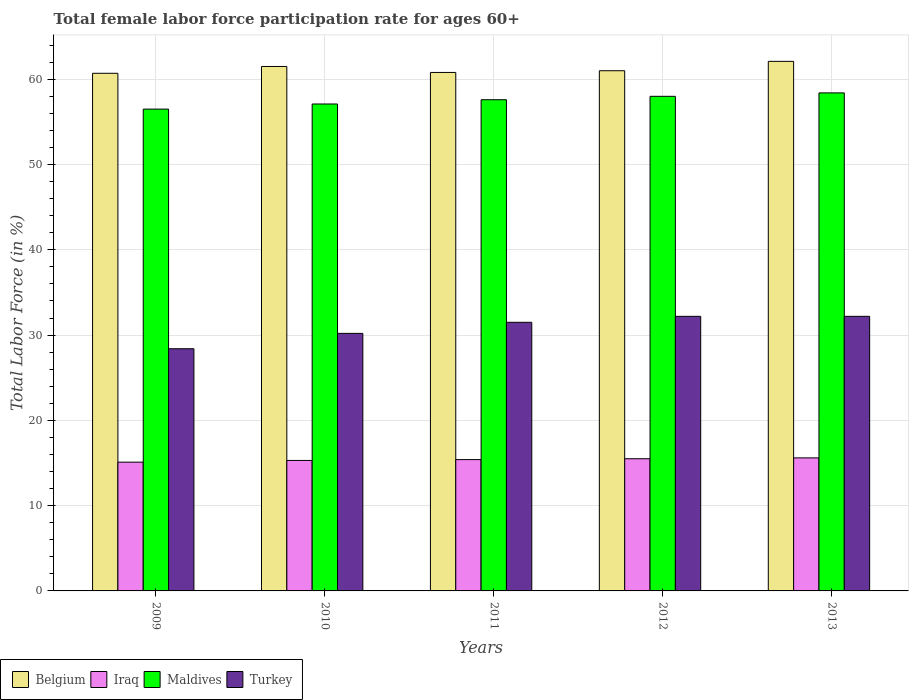How many different coloured bars are there?
Your answer should be compact. 4. How many groups of bars are there?
Your answer should be compact. 5. Are the number of bars per tick equal to the number of legend labels?
Provide a short and direct response. Yes. How many bars are there on the 4th tick from the left?
Your answer should be compact. 4. How many bars are there on the 4th tick from the right?
Offer a very short reply. 4. What is the female labor force participation rate in Iraq in 2012?
Keep it short and to the point. 15.5. Across all years, what is the maximum female labor force participation rate in Belgium?
Keep it short and to the point. 62.1. Across all years, what is the minimum female labor force participation rate in Turkey?
Provide a succinct answer. 28.4. In which year was the female labor force participation rate in Turkey maximum?
Your response must be concise. 2012. In which year was the female labor force participation rate in Maldives minimum?
Your answer should be compact. 2009. What is the total female labor force participation rate in Turkey in the graph?
Offer a terse response. 154.5. What is the difference between the female labor force participation rate in Maldives in 2009 and the female labor force participation rate in Turkey in 2012?
Your response must be concise. 24.3. What is the average female labor force participation rate in Turkey per year?
Ensure brevity in your answer.  30.9. In the year 2011, what is the difference between the female labor force participation rate in Iraq and female labor force participation rate in Maldives?
Offer a terse response. -42.2. In how many years, is the female labor force participation rate in Belgium greater than 40 %?
Offer a terse response. 5. What is the ratio of the female labor force participation rate in Maldives in 2011 to that in 2013?
Keep it short and to the point. 0.99. What is the difference between the highest and the second highest female labor force participation rate in Iraq?
Keep it short and to the point. 0.1. What is the difference between the highest and the lowest female labor force participation rate in Iraq?
Your response must be concise. 0.5. Is the sum of the female labor force participation rate in Iraq in 2010 and 2012 greater than the maximum female labor force participation rate in Maldives across all years?
Give a very brief answer. No. Is it the case that in every year, the sum of the female labor force participation rate in Turkey and female labor force participation rate in Belgium is greater than the sum of female labor force participation rate in Maldives and female labor force participation rate in Iraq?
Offer a very short reply. No. What does the 2nd bar from the right in 2011 represents?
Your response must be concise. Maldives. Are the values on the major ticks of Y-axis written in scientific E-notation?
Provide a short and direct response. No. Does the graph contain any zero values?
Keep it short and to the point. No. Does the graph contain grids?
Give a very brief answer. Yes. How many legend labels are there?
Your answer should be very brief. 4. How are the legend labels stacked?
Your answer should be compact. Horizontal. What is the title of the graph?
Make the answer very short. Total female labor force participation rate for ages 60+. Does "Djibouti" appear as one of the legend labels in the graph?
Offer a terse response. No. What is the Total Labor Force (in %) of Belgium in 2009?
Ensure brevity in your answer.  60.7. What is the Total Labor Force (in %) of Iraq in 2009?
Keep it short and to the point. 15.1. What is the Total Labor Force (in %) of Maldives in 2009?
Give a very brief answer. 56.5. What is the Total Labor Force (in %) in Turkey in 2009?
Your response must be concise. 28.4. What is the Total Labor Force (in %) in Belgium in 2010?
Give a very brief answer. 61.5. What is the Total Labor Force (in %) of Iraq in 2010?
Give a very brief answer. 15.3. What is the Total Labor Force (in %) in Maldives in 2010?
Provide a short and direct response. 57.1. What is the Total Labor Force (in %) of Turkey in 2010?
Your answer should be compact. 30.2. What is the Total Labor Force (in %) of Belgium in 2011?
Offer a terse response. 60.8. What is the Total Labor Force (in %) in Iraq in 2011?
Give a very brief answer. 15.4. What is the Total Labor Force (in %) in Maldives in 2011?
Make the answer very short. 57.6. What is the Total Labor Force (in %) in Turkey in 2011?
Provide a succinct answer. 31.5. What is the Total Labor Force (in %) in Belgium in 2012?
Ensure brevity in your answer.  61. What is the Total Labor Force (in %) in Maldives in 2012?
Keep it short and to the point. 58. What is the Total Labor Force (in %) of Turkey in 2012?
Provide a short and direct response. 32.2. What is the Total Labor Force (in %) of Belgium in 2013?
Provide a short and direct response. 62.1. What is the Total Labor Force (in %) in Iraq in 2013?
Give a very brief answer. 15.6. What is the Total Labor Force (in %) in Maldives in 2013?
Keep it short and to the point. 58.4. What is the Total Labor Force (in %) in Turkey in 2013?
Ensure brevity in your answer.  32.2. Across all years, what is the maximum Total Labor Force (in %) in Belgium?
Your answer should be compact. 62.1. Across all years, what is the maximum Total Labor Force (in %) in Iraq?
Your answer should be very brief. 15.6. Across all years, what is the maximum Total Labor Force (in %) of Maldives?
Provide a short and direct response. 58.4. Across all years, what is the maximum Total Labor Force (in %) in Turkey?
Provide a succinct answer. 32.2. Across all years, what is the minimum Total Labor Force (in %) in Belgium?
Your answer should be very brief. 60.7. Across all years, what is the minimum Total Labor Force (in %) of Iraq?
Make the answer very short. 15.1. Across all years, what is the minimum Total Labor Force (in %) of Maldives?
Offer a very short reply. 56.5. Across all years, what is the minimum Total Labor Force (in %) of Turkey?
Your answer should be very brief. 28.4. What is the total Total Labor Force (in %) of Belgium in the graph?
Ensure brevity in your answer.  306.1. What is the total Total Labor Force (in %) in Iraq in the graph?
Your answer should be compact. 76.9. What is the total Total Labor Force (in %) in Maldives in the graph?
Your answer should be compact. 287.6. What is the total Total Labor Force (in %) in Turkey in the graph?
Keep it short and to the point. 154.5. What is the difference between the Total Labor Force (in %) in Belgium in 2009 and that in 2010?
Your response must be concise. -0.8. What is the difference between the Total Labor Force (in %) of Iraq in 2009 and that in 2010?
Provide a succinct answer. -0.2. What is the difference between the Total Labor Force (in %) of Maldives in 2009 and that in 2010?
Ensure brevity in your answer.  -0.6. What is the difference between the Total Labor Force (in %) of Turkey in 2009 and that in 2010?
Give a very brief answer. -1.8. What is the difference between the Total Labor Force (in %) of Maldives in 2009 and that in 2011?
Your answer should be compact. -1.1. What is the difference between the Total Labor Force (in %) of Turkey in 2009 and that in 2011?
Your response must be concise. -3.1. What is the difference between the Total Labor Force (in %) of Iraq in 2009 and that in 2012?
Your response must be concise. -0.4. What is the difference between the Total Labor Force (in %) of Maldives in 2009 and that in 2012?
Ensure brevity in your answer.  -1.5. What is the difference between the Total Labor Force (in %) of Turkey in 2009 and that in 2012?
Ensure brevity in your answer.  -3.8. What is the difference between the Total Labor Force (in %) in Belgium in 2009 and that in 2013?
Make the answer very short. -1.4. What is the difference between the Total Labor Force (in %) of Belgium in 2010 and that in 2012?
Ensure brevity in your answer.  0.5. What is the difference between the Total Labor Force (in %) of Maldives in 2010 and that in 2012?
Make the answer very short. -0.9. What is the difference between the Total Labor Force (in %) of Belgium in 2010 and that in 2013?
Keep it short and to the point. -0.6. What is the difference between the Total Labor Force (in %) of Maldives in 2010 and that in 2013?
Ensure brevity in your answer.  -1.3. What is the difference between the Total Labor Force (in %) in Belgium in 2011 and that in 2012?
Make the answer very short. -0.2. What is the difference between the Total Labor Force (in %) of Iraq in 2011 and that in 2012?
Provide a short and direct response. -0.1. What is the difference between the Total Labor Force (in %) in Maldives in 2011 and that in 2012?
Your answer should be compact. -0.4. What is the difference between the Total Labor Force (in %) of Belgium in 2011 and that in 2013?
Offer a terse response. -1.3. What is the difference between the Total Labor Force (in %) in Maldives in 2011 and that in 2013?
Your answer should be compact. -0.8. What is the difference between the Total Labor Force (in %) in Belgium in 2012 and that in 2013?
Offer a very short reply. -1.1. What is the difference between the Total Labor Force (in %) of Iraq in 2012 and that in 2013?
Provide a short and direct response. -0.1. What is the difference between the Total Labor Force (in %) of Maldives in 2012 and that in 2013?
Keep it short and to the point. -0.4. What is the difference between the Total Labor Force (in %) of Belgium in 2009 and the Total Labor Force (in %) of Iraq in 2010?
Your response must be concise. 45.4. What is the difference between the Total Labor Force (in %) of Belgium in 2009 and the Total Labor Force (in %) of Maldives in 2010?
Keep it short and to the point. 3.6. What is the difference between the Total Labor Force (in %) of Belgium in 2009 and the Total Labor Force (in %) of Turkey in 2010?
Give a very brief answer. 30.5. What is the difference between the Total Labor Force (in %) in Iraq in 2009 and the Total Labor Force (in %) in Maldives in 2010?
Keep it short and to the point. -42. What is the difference between the Total Labor Force (in %) of Iraq in 2009 and the Total Labor Force (in %) of Turkey in 2010?
Make the answer very short. -15.1. What is the difference between the Total Labor Force (in %) in Maldives in 2009 and the Total Labor Force (in %) in Turkey in 2010?
Provide a short and direct response. 26.3. What is the difference between the Total Labor Force (in %) of Belgium in 2009 and the Total Labor Force (in %) of Iraq in 2011?
Your answer should be very brief. 45.3. What is the difference between the Total Labor Force (in %) in Belgium in 2009 and the Total Labor Force (in %) in Maldives in 2011?
Offer a terse response. 3.1. What is the difference between the Total Labor Force (in %) in Belgium in 2009 and the Total Labor Force (in %) in Turkey in 2011?
Your answer should be compact. 29.2. What is the difference between the Total Labor Force (in %) of Iraq in 2009 and the Total Labor Force (in %) of Maldives in 2011?
Your answer should be very brief. -42.5. What is the difference between the Total Labor Force (in %) in Iraq in 2009 and the Total Labor Force (in %) in Turkey in 2011?
Your answer should be very brief. -16.4. What is the difference between the Total Labor Force (in %) of Belgium in 2009 and the Total Labor Force (in %) of Iraq in 2012?
Make the answer very short. 45.2. What is the difference between the Total Labor Force (in %) in Belgium in 2009 and the Total Labor Force (in %) in Maldives in 2012?
Your answer should be compact. 2.7. What is the difference between the Total Labor Force (in %) in Belgium in 2009 and the Total Labor Force (in %) in Turkey in 2012?
Provide a succinct answer. 28.5. What is the difference between the Total Labor Force (in %) of Iraq in 2009 and the Total Labor Force (in %) of Maldives in 2012?
Your answer should be very brief. -42.9. What is the difference between the Total Labor Force (in %) of Iraq in 2009 and the Total Labor Force (in %) of Turkey in 2012?
Provide a succinct answer. -17.1. What is the difference between the Total Labor Force (in %) in Maldives in 2009 and the Total Labor Force (in %) in Turkey in 2012?
Ensure brevity in your answer.  24.3. What is the difference between the Total Labor Force (in %) in Belgium in 2009 and the Total Labor Force (in %) in Iraq in 2013?
Offer a terse response. 45.1. What is the difference between the Total Labor Force (in %) of Belgium in 2009 and the Total Labor Force (in %) of Turkey in 2013?
Provide a succinct answer. 28.5. What is the difference between the Total Labor Force (in %) of Iraq in 2009 and the Total Labor Force (in %) of Maldives in 2013?
Your answer should be compact. -43.3. What is the difference between the Total Labor Force (in %) of Iraq in 2009 and the Total Labor Force (in %) of Turkey in 2013?
Give a very brief answer. -17.1. What is the difference between the Total Labor Force (in %) in Maldives in 2009 and the Total Labor Force (in %) in Turkey in 2013?
Your answer should be compact. 24.3. What is the difference between the Total Labor Force (in %) in Belgium in 2010 and the Total Labor Force (in %) in Iraq in 2011?
Provide a short and direct response. 46.1. What is the difference between the Total Labor Force (in %) of Iraq in 2010 and the Total Labor Force (in %) of Maldives in 2011?
Provide a short and direct response. -42.3. What is the difference between the Total Labor Force (in %) in Iraq in 2010 and the Total Labor Force (in %) in Turkey in 2011?
Give a very brief answer. -16.2. What is the difference between the Total Labor Force (in %) of Maldives in 2010 and the Total Labor Force (in %) of Turkey in 2011?
Provide a succinct answer. 25.6. What is the difference between the Total Labor Force (in %) of Belgium in 2010 and the Total Labor Force (in %) of Iraq in 2012?
Give a very brief answer. 46. What is the difference between the Total Labor Force (in %) of Belgium in 2010 and the Total Labor Force (in %) of Maldives in 2012?
Make the answer very short. 3.5. What is the difference between the Total Labor Force (in %) of Belgium in 2010 and the Total Labor Force (in %) of Turkey in 2012?
Your answer should be compact. 29.3. What is the difference between the Total Labor Force (in %) of Iraq in 2010 and the Total Labor Force (in %) of Maldives in 2012?
Offer a very short reply. -42.7. What is the difference between the Total Labor Force (in %) of Iraq in 2010 and the Total Labor Force (in %) of Turkey in 2012?
Provide a succinct answer. -16.9. What is the difference between the Total Labor Force (in %) of Maldives in 2010 and the Total Labor Force (in %) of Turkey in 2012?
Provide a short and direct response. 24.9. What is the difference between the Total Labor Force (in %) in Belgium in 2010 and the Total Labor Force (in %) in Iraq in 2013?
Your answer should be compact. 45.9. What is the difference between the Total Labor Force (in %) of Belgium in 2010 and the Total Labor Force (in %) of Maldives in 2013?
Ensure brevity in your answer.  3.1. What is the difference between the Total Labor Force (in %) of Belgium in 2010 and the Total Labor Force (in %) of Turkey in 2013?
Keep it short and to the point. 29.3. What is the difference between the Total Labor Force (in %) of Iraq in 2010 and the Total Labor Force (in %) of Maldives in 2013?
Make the answer very short. -43.1. What is the difference between the Total Labor Force (in %) in Iraq in 2010 and the Total Labor Force (in %) in Turkey in 2013?
Provide a succinct answer. -16.9. What is the difference between the Total Labor Force (in %) in Maldives in 2010 and the Total Labor Force (in %) in Turkey in 2013?
Make the answer very short. 24.9. What is the difference between the Total Labor Force (in %) in Belgium in 2011 and the Total Labor Force (in %) in Iraq in 2012?
Offer a very short reply. 45.3. What is the difference between the Total Labor Force (in %) in Belgium in 2011 and the Total Labor Force (in %) in Turkey in 2012?
Provide a succinct answer. 28.6. What is the difference between the Total Labor Force (in %) of Iraq in 2011 and the Total Labor Force (in %) of Maldives in 2012?
Provide a succinct answer. -42.6. What is the difference between the Total Labor Force (in %) of Iraq in 2011 and the Total Labor Force (in %) of Turkey in 2012?
Your answer should be compact. -16.8. What is the difference between the Total Labor Force (in %) in Maldives in 2011 and the Total Labor Force (in %) in Turkey in 2012?
Offer a terse response. 25.4. What is the difference between the Total Labor Force (in %) of Belgium in 2011 and the Total Labor Force (in %) of Iraq in 2013?
Your response must be concise. 45.2. What is the difference between the Total Labor Force (in %) of Belgium in 2011 and the Total Labor Force (in %) of Maldives in 2013?
Make the answer very short. 2.4. What is the difference between the Total Labor Force (in %) in Belgium in 2011 and the Total Labor Force (in %) in Turkey in 2013?
Provide a succinct answer. 28.6. What is the difference between the Total Labor Force (in %) of Iraq in 2011 and the Total Labor Force (in %) of Maldives in 2013?
Your response must be concise. -43. What is the difference between the Total Labor Force (in %) of Iraq in 2011 and the Total Labor Force (in %) of Turkey in 2013?
Your answer should be compact. -16.8. What is the difference between the Total Labor Force (in %) of Maldives in 2011 and the Total Labor Force (in %) of Turkey in 2013?
Keep it short and to the point. 25.4. What is the difference between the Total Labor Force (in %) of Belgium in 2012 and the Total Labor Force (in %) of Iraq in 2013?
Provide a succinct answer. 45.4. What is the difference between the Total Labor Force (in %) of Belgium in 2012 and the Total Labor Force (in %) of Maldives in 2013?
Keep it short and to the point. 2.6. What is the difference between the Total Labor Force (in %) of Belgium in 2012 and the Total Labor Force (in %) of Turkey in 2013?
Give a very brief answer. 28.8. What is the difference between the Total Labor Force (in %) of Iraq in 2012 and the Total Labor Force (in %) of Maldives in 2013?
Offer a terse response. -42.9. What is the difference between the Total Labor Force (in %) of Iraq in 2012 and the Total Labor Force (in %) of Turkey in 2013?
Ensure brevity in your answer.  -16.7. What is the difference between the Total Labor Force (in %) of Maldives in 2012 and the Total Labor Force (in %) of Turkey in 2013?
Ensure brevity in your answer.  25.8. What is the average Total Labor Force (in %) in Belgium per year?
Ensure brevity in your answer.  61.22. What is the average Total Labor Force (in %) in Iraq per year?
Offer a terse response. 15.38. What is the average Total Labor Force (in %) of Maldives per year?
Your answer should be compact. 57.52. What is the average Total Labor Force (in %) of Turkey per year?
Provide a succinct answer. 30.9. In the year 2009, what is the difference between the Total Labor Force (in %) of Belgium and Total Labor Force (in %) of Iraq?
Offer a terse response. 45.6. In the year 2009, what is the difference between the Total Labor Force (in %) of Belgium and Total Labor Force (in %) of Turkey?
Keep it short and to the point. 32.3. In the year 2009, what is the difference between the Total Labor Force (in %) of Iraq and Total Labor Force (in %) of Maldives?
Offer a very short reply. -41.4. In the year 2009, what is the difference between the Total Labor Force (in %) in Maldives and Total Labor Force (in %) in Turkey?
Ensure brevity in your answer.  28.1. In the year 2010, what is the difference between the Total Labor Force (in %) of Belgium and Total Labor Force (in %) of Iraq?
Your answer should be very brief. 46.2. In the year 2010, what is the difference between the Total Labor Force (in %) of Belgium and Total Labor Force (in %) of Turkey?
Your response must be concise. 31.3. In the year 2010, what is the difference between the Total Labor Force (in %) in Iraq and Total Labor Force (in %) in Maldives?
Provide a succinct answer. -41.8. In the year 2010, what is the difference between the Total Labor Force (in %) in Iraq and Total Labor Force (in %) in Turkey?
Provide a short and direct response. -14.9. In the year 2010, what is the difference between the Total Labor Force (in %) of Maldives and Total Labor Force (in %) of Turkey?
Offer a very short reply. 26.9. In the year 2011, what is the difference between the Total Labor Force (in %) of Belgium and Total Labor Force (in %) of Iraq?
Provide a short and direct response. 45.4. In the year 2011, what is the difference between the Total Labor Force (in %) of Belgium and Total Labor Force (in %) of Turkey?
Give a very brief answer. 29.3. In the year 2011, what is the difference between the Total Labor Force (in %) of Iraq and Total Labor Force (in %) of Maldives?
Offer a terse response. -42.2. In the year 2011, what is the difference between the Total Labor Force (in %) in Iraq and Total Labor Force (in %) in Turkey?
Offer a terse response. -16.1. In the year 2011, what is the difference between the Total Labor Force (in %) in Maldives and Total Labor Force (in %) in Turkey?
Your answer should be compact. 26.1. In the year 2012, what is the difference between the Total Labor Force (in %) in Belgium and Total Labor Force (in %) in Iraq?
Keep it short and to the point. 45.5. In the year 2012, what is the difference between the Total Labor Force (in %) in Belgium and Total Labor Force (in %) in Maldives?
Your answer should be very brief. 3. In the year 2012, what is the difference between the Total Labor Force (in %) of Belgium and Total Labor Force (in %) of Turkey?
Your answer should be compact. 28.8. In the year 2012, what is the difference between the Total Labor Force (in %) in Iraq and Total Labor Force (in %) in Maldives?
Your answer should be compact. -42.5. In the year 2012, what is the difference between the Total Labor Force (in %) in Iraq and Total Labor Force (in %) in Turkey?
Offer a terse response. -16.7. In the year 2012, what is the difference between the Total Labor Force (in %) in Maldives and Total Labor Force (in %) in Turkey?
Offer a terse response. 25.8. In the year 2013, what is the difference between the Total Labor Force (in %) of Belgium and Total Labor Force (in %) of Iraq?
Offer a very short reply. 46.5. In the year 2013, what is the difference between the Total Labor Force (in %) of Belgium and Total Labor Force (in %) of Turkey?
Your response must be concise. 29.9. In the year 2013, what is the difference between the Total Labor Force (in %) in Iraq and Total Labor Force (in %) in Maldives?
Make the answer very short. -42.8. In the year 2013, what is the difference between the Total Labor Force (in %) of Iraq and Total Labor Force (in %) of Turkey?
Offer a very short reply. -16.6. In the year 2013, what is the difference between the Total Labor Force (in %) of Maldives and Total Labor Force (in %) of Turkey?
Provide a succinct answer. 26.2. What is the ratio of the Total Labor Force (in %) in Iraq in 2009 to that in 2010?
Provide a succinct answer. 0.99. What is the ratio of the Total Labor Force (in %) in Maldives in 2009 to that in 2010?
Keep it short and to the point. 0.99. What is the ratio of the Total Labor Force (in %) in Turkey in 2009 to that in 2010?
Keep it short and to the point. 0.94. What is the ratio of the Total Labor Force (in %) in Iraq in 2009 to that in 2011?
Provide a short and direct response. 0.98. What is the ratio of the Total Labor Force (in %) of Maldives in 2009 to that in 2011?
Give a very brief answer. 0.98. What is the ratio of the Total Labor Force (in %) in Turkey in 2009 to that in 2011?
Provide a succinct answer. 0.9. What is the ratio of the Total Labor Force (in %) in Iraq in 2009 to that in 2012?
Offer a terse response. 0.97. What is the ratio of the Total Labor Force (in %) in Maldives in 2009 to that in 2012?
Your answer should be very brief. 0.97. What is the ratio of the Total Labor Force (in %) of Turkey in 2009 to that in 2012?
Keep it short and to the point. 0.88. What is the ratio of the Total Labor Force (in %) in Belgium in 2009 to that in 2013?
Give a very brief answer. 0.98. What is the ratio of the Total Labor Force (in %) in Iraq in 2009 to that in 2013?
Provide a short and direct response. 0.97. What is the ratio of the Total Labor Force (in %) in Maldives in 2009 to that in 2013?
Make the answer very short. 0.97. What is the ratio of the Total Labor Force (in %) of Turkey in 2009 to that in 2013?
Keep it short and to the point. 0.88. What is the ratio of the Total Labor Force (in %) in Belgium in 2010 to that in 2011?
Provide a succinct answer. 1.01. What is the ratio of the Total Labor Force (in %) in Maldives in 2010 to that in 2011?
Keep it short and to the point. 0.99. What is the ratio of the Total Labor Force (in %) of Turkey in 2010 to that in 2011?
Make the answer very short. 0.96. What is the ratio of the Total Labor Force (in %) of Belgium in 2010 to that in 2012?
Provide a short and direct response. 1.01. What is the ratio of the Total Labor Force (in %) in Iraq in 2010 to that in 2012?
Offer a very short reply. 0.99. What is the ratio of the Total Labor Force (in %) in Maldives in 2010 to that in 2012?
Give a very brief answer. 0.98. What is the ratio of the Total Labor Force (in %) in Turkey in 2010 to that in 2012?
Provide a short and direct response. 0.94. What is the ratio of the Total Labor Force (in %) of Belgium in 2010 to that in 2013?
Keep it short and to the point. 0.99. What is the ratio of the Total Labor Force (in %) in Iraq in 2010 to that in 2013?
Offer a terse response. 0.98. What is the ratio of the Total Labor Force (in %) of Maldives in 2010 to that in 2013?
Your answer should be compact. 0.98. What is the ratio of the Total Labor Force (in %) of Turkey in 2010 to that in 2013?
Provide a short and direct response. 0.94. What is the ratio of the Total Labor Force (in %) of Turkey in 2011 to that in 2012?
Make the answer very short. 0.98. What is the ratio of the Total Labor Force (in %) in Belgium in 2011 to that in 2013?
Provide a succinct answer. 0.98. What is the ratio of the Total Labor Force (in %) of Iraq in 2011 to that in 2013?
Give a very brief answer. 0.99. What is the ratio of the Total Labor Force (in %) in Maldives in 2011 to that in 2013?
Your answer should be very brief. 0.99. What is the ratio of the Total Labor Force (in %) of Turkey in 2011 to that in 2013?
Provide a succinct answer. 0.98. What is the ratio of the Total Labor Force (in %) in Belgium in 2012 to that in 2013?
Ensure brevity in your answer.  0.98. What is the ratio of the Total Labor Force (in %) in Iraq in 2012 to that in 2013?
Give a very brief answer. 0.99. What is the ratio of the Total Labor Force (in %) in Maldives in 2012 to that in 2013?
Your answer should be very brief. 0.99. What is the ratio of the Total Labor Force (in %) in Turkey in 2012 to that in 2013?
Offer a terse response. 1. What is the difference between the highest and the second highest Total Labor Force (in %) in Belgium?
Ensure brevity in your answer.  0.6. What is the difference between the highest and the second highest Total Labor Force (in %) of Maldives?
Your answer should be compact. 0.4. What is the difference between the highest and the second highest Total Labor Force (in %) in Turkey?
Keep it short and to the point. 0. What is the difference between the highest and the lowest Total Labor Force (in %) of Belgium?
Provide a short and direct response. 1.4. What is the difference between the highest and the lowest Total Labor Force (in %) in Turkey?
Keep it short and to the point. 3.8. 